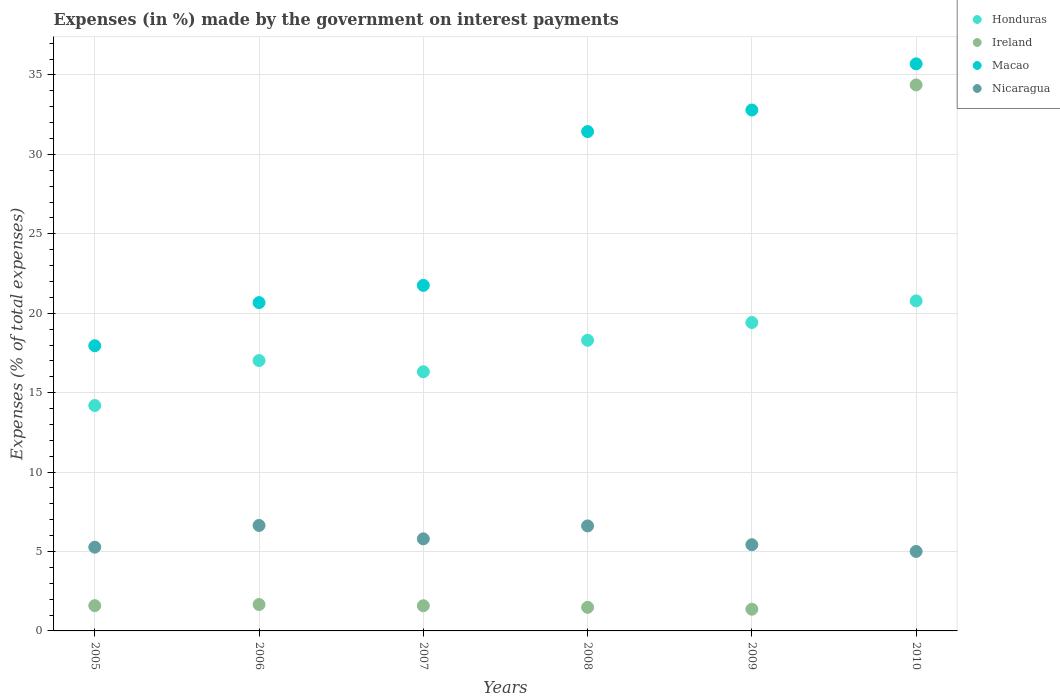What is the percentage of expenses made by the government on interest payments in Ireland in 2006?
Offer a terse response. 1.66. Across all years, what is the maximum percentage of expenses made by the government on interest payments in Macao?
Your answer should be very brief. 35.7. Across all years, what is the minimum percentage of expenses made by the government on interest payments in Honduras?
Your answer should be compact. 14.19. In which year was the percentage of expenses made by the government on interest payments in Macao maximum?
Offer a very short reply. 2010. In which year was the percentage of expenses made by the government on interest payments in Ireland minimum?
Offer a terse response. 2009. What is the total percentage of expenses made by the government on interest payments in Ireland in the graph?
Your answer should be very brief. 42.06. What is the difference between the percentage of expenses made by the government on interest payments in Ireland in 2008 and that in 2010?
Make the answer very short. -32.89. What is the difference between the percentage of expenses made by the government on interest payments in Nicaragua in 2006 and the percentage of expenses made by the government on interest payments in Macao in 2005?
Make the answer very short. -11.31. What is the average percentage of expenses made by the government on interest payments in Macao per year?
Give a very brief answer. 26.72. In the year 2006, what is the difference between the percentage of expenses made by the government on interest payments in Macao and percentage of expenses made by the government on interest payments in Nicaragua?
Your answer should be very brief. 14.03. In how many years, is the percentage of expenses made by the government on interest payments in Honduras greater than 29 %?
Make the answer very short. 0. What is the ratio of the percentage of expenses made by the government on interest payments in Nicaragua in 2005 to that in 2009?
Your answer should be very brief. 0.97. What is the difference between the highest and the second highest percentage of expenses made by the government on interest payments in Nicaragua?
Offer a very short reply. 0.03. What is the difference between the highest and the lowest percentage of expenses made by the government on interest payments in Nicaragua?
Offer a terse response. 1.64. In how many years, is the percentage of expenses made by the government on interest payments in Nicaragua greater than the average percentage of expenses made by the government on interest payments in Nicaragua taken over all years?
Provide a succinct answer. 3. Is the sum of the percentage of expenses made by the government on interest payments in Ireland in 2006 and 2008 greater than the maximum percentage of expenses made by the government on interest payments in Honduras across all years?
Offer a very short reply. No. Is it the case that in every year, the sum of the percentage of expenses made by the government on interest payments in Honduras and percentage of expenses made by the government on interest payments in Ireland  is greater than the sum of percentage of expenses made by the government on interest payments in Macao and percentage of expenses made by the government on interest payments in Nicaragua?
Your answer should be compact. Yes. Is the percentage of expenses made by the government on interest payments in Macao strictly less than the percentage of expenses made by the government on interest payments in Nicaragua over the years?
Your answer should be very brief. No. How many dotlines are there?
Make the answer very short. 4. What is the difference between two consecutive major ticks on the Y-axis?
Your response must be concise. 5. Are the values on the major ticks of Y-axis written in scientific E-notation?
Your response must be concise. No. Does the graph contain any zero values?
Make the answer very short. No. Does the graph contain grids?
Your answer should be compact. Yes. Where does the legend appear in the graph?
Your response must be concise. Top right. How are the legend labels stacked?
Your response must be concise. Vertical. What is the title of the graph?
Offer a very short reply. Expenses (in %) made by the government on interest payments. What is the label or title of the X-axis?
Offer a very short reply. Years. What is the label or title of the Y-axis?
Keep it short and to the point. Expenses (% of total expenses). What is the Expenses (% of total expenses) of Honduras in 2005?
Your answer should be compact. 14.19. What is the Expenses (% of total expenses) of Ireland in 2005?
Provide a succinct answer. 1.59. What is the Expenses (% of total expenses) of Macao in 2005?
Give a very brief answer. 17.95. What is the Expenses (% of total expenses) in Nicaragua in 2005?
Keep it short and to the point. 5.27. What is the Expenses (% of total expenses) of Honduras in 2006?
Provide a succinct answer. 17.02. What is the Expenses (% of total expenses) of Ireland in 2006?
Make the answer very short. 1.66. What is the Expenses (% of total expenses) in Macao in 2006?
Your answer should be very brief. 20.67. What is the Expenses (% of total expenses) of Nicaragua in 2006?
Make the answer very short. 6.64. What is the Expenses (% of total expenses) in Honduras in 2007?
Your answer should be very brief. 16.32. What is the Expenses (% of total expenses) of Ireland in 2007?
Your answer should be very brief. 1.58. What is the Expenses (% of total expenses) in Macao in 2007?
Make the answer very short. 21.75. What is the Expenses (% of total expenses) of Nicaragua in 2007?
Ensure brevity in your answer.  5.8. What is the Expenses (% of total expenses) in Honduras in 2008?
Offer a very short reply. 18.3. What is the Expenses (% of total expenses) of Ireland in 2008?
Give a very brief answer. 1.49. What is the Expenses (% of total expenses) in Macao in 2008?
Your answer should be very brief. 31.44. What is the Expenses (% of total expenses) of Nicaragua in 2008?
Provide a succinct answer. 6.61. What is the Expenses (% of total expenses) in Honduras in 2009?
Your response must be concise. 19.42. What is the Expenses (% of total expenses) of Ireland in 2009?
Your response must be concise. 1.37. What is the Expenses (% of total expenses) of Macao in 2009?
Ensure brevity in your answer.  32.8. What is the Expenses (% of total expenses) of Nicaragua in 2009?
Ensure brevity in your answer.  5.43. What is the Expenses (% of total expenses) in Honduras in 2010?
Offer a very short reply. 20.78. What is the Expenses (% of total expenses) in Ireland in 2010?
Make the answer very short. 34.37. What is the Expenses (% of total expenses) of Macao in 2010?
Offer a very short reply. 35.7. What is the Expenses (% of total expenses) in Nicaragua in 2010?
Give a very brief answer. 5. Across all years, what is the maximum Expenses (% of total expenses) in Honduras?
Offer a terse response. 20.78. Across all years, what is the maximum Expenses (% of total expenses) in Ireland?
Ensure brevity in your answer.  34.37. Across all years, what is the maximum Expenses (% of total expenses) of Macao?
Provide a short and direct response. 35.7. Across all years, what is the maximum Expenses (% of total expenses) of Nicaragua?
Keep it short and to the point. 6.64. Across all years, what is the minimum Expenses (% of total expenses) of Honduras?
Keep it short and to the point. 14.19. Across all years, what is the minimum Expenses (% of total expenses) in Ireland?
Your answer should be compact. 1.37. Across all years, what is the minimum Expenses (% of total expenses) in Macao?
Ensure brevity in your answer.  17.95. Across all years, what is the minimum Expenses (% of total expenses) in Nicaragua?
Your response must be concise. 5. What is the total Expenses (% of total expenses) in Honduras in the graph?
Offer a very short reply. 106.02. What is the total Expenses (% of total expenses) of Ireland in the graph?
Give a very brief answer. 42.06. What is the total Expenses (% of total expenses) in Macao in the graph?
Ensure brevity in your answer.  160.31. What is the total Expenses (% of total expenses) in Nicaragua in the graph?
Ensure brevity in your answer.  34.75. What is the difference between the Expenses (% of total expenses) of Honduras in 2005 and that in 2006?
Ensure brevity in your answer.  -2.83. What is the difference between the Expenses (% of total expenses) of Ireland in 2005 and that in 2006?
Provide a short and direct response. -0.07. What is the difference between the Expenses (% of total expenses) of Macao in 2005 and that in 2006?
Ensure brevity in your answer.  -2.72. What is the difference between the Expenses (% of total expenses) of Nicaragua in 2005 and that in 2006?
Keep it short and to the point. -1.37. What is the difference between the Expenses (% of total expenses) in Honduras in 2005 and that in 2007?
Provide a succinct answer. -2.13. What is the difference between the Expenses (% of total expenses) in Ireland in 2005 and that in 2007?
Your response must be concise. 0.01. What is the difference between the Expenses (% of total expenses) of Macao in 2005 and that in 2007?
Provide a succinct answer. -3.8. What is the difference between the Expenses (% of total expenses) of Nicaragua in 2005 and that in 2007?
Your answer should be very brief. -0.52. What is the difference between the Expenses (% of total expenses) of Honduras in 2005 and that in 2008?
Offer a very short reply. -4.11. What is the difference between the Expenses (% of total expenses) in Ireland in 2005 and that in 2008?
Offer a terse response. 0.1. What is the difference between the Expenses (% of total expenses) of Macao in 2005 and that in 2008?
Your answer should be very brief. -13.48. What is the difference between the Expenses (% of total expenses) of Nicaragua in 2005 and that in 2008?
Your answer should be very brief. -1.34. What is the difference between the Expenses (% of total expenses) in Honduras in 2005 and that in 2009?
Offer a terse response. -5.23. What is the difference between the Expenses (% of total expenses) in Ireland in 2005 and that in 2009?
Offer a terse response. 0.22. What is the difference between the Expenses (% of total expenses) of Macao in 2005 and that in 2009?
Offer a very short reply. -14.84. What is the difference between the Expenses (% of total expenses) in Nicaragua in 2005 and that in 2009?
Provide a succinct answer. -0.15. What is the difference between the Expenses (% of total expenses) in Honduras in 2005 and that in 2010?
Your answer should be very brief. -6.59. What is the difference between the Expenses (% of total expenses) in Ireland in 2005 and that in 2010?
Offer a very short reply. -32.78. What is the difference between the Expenses (% of total expenses) in Macao in 2005 and that in 2010?
Offer a very short reply. -17.75. What is the difference between the Expenses (% of total expenses) of Nicaragua in 2005 and that in 2010?
Provide a short and direct response. 0.27. What is the difference between the Expenses (% of total expenses) of Honduras in 2006 and that in 2007?
Offer a very short reply. 0.7. What is the difference between the Expenses (% of total expenses) in Ireland in 2006 and that in 2007?
Provide a short and direct response. 0.08. What is the difference between the Expenses (% of total expenses) of Macao in 2006 and that in 2007?
Offer a very short reply. -1.08. What is the difference between the Expenses (% of total expenses) of Nicaragua in 2006 and that in 2007?
Ensure brevity in your answer.  0.84. What is the difference between the Expenses (% of total expenses) in Honduras in 2006 and that in 2008?
Your answer should be compact. -1.28. What is the difference between the Expenses (% of total expenses) of Ireland in 2006 and that in 2008?
Your answer should be very brief. 0.18. What is the difference between the Expenses (% of total expenses) of Macao in 2006 and that in 2008?
Ensure brevity in your answer.  -10.77. What is the difference between the Expenses (% of total expenses) in Nicaragua in 2006 and that in 2008?
Make the answer very short. 0.03. What is the difference between the Expenses (% of total expenses) of Honduras in 2006 and that in 2009?
Provide a succinct answer. -2.39. What is the difference between the Expenses (% of total expenses) of Ireland in 2006 and that in 2009?
Provide a short and direct response. 0.3. What is the difference between the Expenses (% of total expenses) in Macao in 2006 and that in 2009?
Ensure brevity in your answer.  -12.13. What is the difference between the Expenses (% of total expenses) in Nicaragua in 2006 and that in 2009?
Offer a terse response. 1.21. What is the difference between the Expenses (% of total expenses) in Honduras in 2006 and that in 2010?
Provide a short and direct response. -3.76. What is the difference between the Expenses (% of total expenses) in Ireland in 2006 and that in 2010?
Keep it short and to the point. -32.71. What is the difference between the Expenses (% of total expenses) of Macao in 2006 and that in 2010?
Keep it short and to the point. -15.03. What is the difference between the Expenses (% of total expenses) of Nicaragua in 2006 and that in 2010?
Give a very brief answer. 1.64. What is the difference between the Expenses (% of total expenses) of Honduras in 2007 and that in 2008?
Your answer should be compact. -1.98. What is the difference between the Expenses (% of total expenses) of Ireland in 2007 and that in 2008?
Make the answer very short. 0.1. What is the difference between the Expenses (% of total expenses) of Macao in 2007 and that in 2008?
Your answer should be very brief. -9.68. What is the difference between the Expenses (% of total expenses) of Nicaragua in 2007 and that in 2008?
Give a very brief answer. -0.81. What is the difference between the Expenses (% of total expenses) of Honduras in 2007 and that in 2009?
Offer a very short reply. -3.1. What is the difference between the Expenses (% of total expenses) in Ireland in 2007 and that in 2009?
Provide a succinct answer. 0.22. What is the difference between the Expenses (% of total expenses) in Macao in 2007 and that in 2009?
Ensure brevity in your answer.  -11.04. What is the difference between the Expenses (% of total expenses) of Nicaragua in 2007 and that in 2009?
Your answer should be very brief. 0.37. What is the difference between the Expenses (% of total expenses) of Honduras in 2007 and that in 2010?
Your answer should be compact. -4.46. What is the difference between the Expenses (% of total expenses) in Ireland in 2007 and that in 2010?
Your answer should be compact. -32.79. What is the difference between the Expenses (% of total expenses) of Macao in 2007 and that in 2010?
Offer a terse response. -13.95. What is the difference between the Expenses (% of total expenses) in Nicaragua in 2007 and that in 2010?
Your response must be concise. 0.79. What is the difference between the Expenses (% of total expenses) in Honduras in 2008 and that in 2009?
Make the answer very short. -1.12. What is the difference between the Expenses (% of total expenses) of Ireland in 2008 and that in 2009?
Keep it short and to the point. 0.12. What is the difference between the Expenses (% of total expenses) in Macao in 2008 and that in 2009?
Your answer should be compact. -1.36. What is the difference between the Expenses (% of total expenses) in Nicaragua in 2008 and that in 2009?
Provide a short and direct response. 1.18. What is the difference between the Expenses (% of total expenses) of Honduras in 2008 and that in 2010?
Offer a very short reply. -2.48. What is the difference between the Expenses (% of total expenses) in Ireland in 2008 and that in 2010?
Give a very brief answer. -32.89. What is the difference between the Expenses (% of total expenses) in Macao in 2008 and that in 2010?
Your answer should be compact. -4.26. What is the difference between the Expenses (% of total expenses) in Nicaragua in 2008 and that in 2010?
Your answer should be very brief. 1.61. What is the difference between the Expenses (% of total expenses) in Honduras in 2009 and that in 2010?
Your response must be concise. -1.36. What is the difference between the Expenses (% of total expenses) of Ireland in 2009 and that in 2010?
Your answer should be compact. -33.01. What is the difference between the Expenses (% of total expenses) in Macao in 2009 and that in 2010?
Offer a very short reply. -2.91. What is the difference between the Expenses (% of total expenses) of Nicaragua in 2009 and that in 2010?
Your answer should be very brief. 0.42. What is the difference between the Expenses (% of total expenses) in Honduras in 2005 and the Expenses (% of total expenses) in Ireland in 2006?
Ensure brevity in your answer.  12.53. What is the difference between the Expenses (% of total expenses) in Honduras in 2005 and the Expenses (% of total expenses) in Macao in 2006?
Ensure brevity in your answer.  -6.48. What is the difference between the Expenses (% of total expenses) of Honduras in 2005 and the Expenses (% of total expenses) of Nicaragua in 2006?
Ensure brevity in your answer.  7.55. What is the difference between the Expenses (% of total expenses) of Ireland in 2005 and the Expenses (% of total expenses) of Macao in 2006?
Provide a short and direct response. -19.08. What is the difference between the Expenses (% of total expenses) in Ireland in 2005 and the Expenses (% of total expenses) in Nicaragua in 2006?
Your response must be concise. -5.05. What is the difference between the Expenses (% of total expenses) in Macao in 2005 and the Expenses (% of total expenses) in Nicaragua in 2006?
Provide a succinct answer. 11.31. What is the difference between the Expenses (% of total expenses) in Honduras in 2005 and the Expenses (% of total expenses) in Ireland in 2007?
Ensure brevity in your answer.  12.61. What is the difference between the Expenses (% of total expenses) of Honduras in 2005 and the Expenses (% of total expenses) of Macao in 2007?
Give a very brief answer. -7.56. What is the difference between the Expenses (% of total expenses) in Honduras in 2005 and the Expenses (% of total expenses) in Nicaragua in 2007?
Provide a succinct answer. 8.39. What is the difference between the Expenses (% of total expenses) in Ireland in 2005 and the Expenses (% of total expenses) in Macao in 2007?
Keep it short and to the point. -20.16. What is the difference between the Expenses (% of total expenses) in Ireland in 2005 and the Expenses (% of total expenses) in Nicaragua in 2007?
Ensure brevity in your answer.  -4.21. What is the difference between the Expenses (% of total expenses) in Macao in 2005 and the Expenses (% of total expenses) in Nicaragua in 2007?
Keep it short and to the point. 12.16. What is the difference between the Expenses (% of total expenses) in Honduras in 2005 and the Expenses (% of total expenses) in Ireland in 2008?
Offer a terse response. 12.7. What is the difference between the Expenses (% of total expenses) in Honduras in 2005 and the Expenses (% of total expenses) in Macao in 2008?
Your answer should be compact. -17.25. What is the difference between the Expenses (% of total expenses) of Honduras in 2005 and the Expenses (% of total expenses) of Nicaragua in 2008?
Your answer should be very brief. 7.58. What is the difference between the Expenses (% of total expenses) in Ireland in 2005 and the Expenses (% of total expenses) in Macao in 2008?
Make the answer very short. -29.85. What is the difference between the Expenses (% of total expenses) of Ireland in 2005 and the Expenses (% of total expenses) of Nicaragua in 2008?
Offer a very short reply. -5.02. What is the difference between the Expenses (% of total expenses) in Macao in 2005 and the Expenses (% of total expenses) in Nicaragua in 2008?
Offer a terse response. 11.34. What is the difference between the Expenses (% of total expenses) of Honduras in 2005 and the Expenses (% of total expenses) of Ireland in 2009?
Ensure brevity in your answer.  12.82. What is the difference between the Expenses (% of total expenses) in Honduras in 2005 and the Expenses (% of total expenses) in Macao in 2009?
Ensure brevity in your answer.  -18.61. What is the difference between the Expenses (% of total expenses) of Honduras in 2005 and the Expenses (% of total expenses) of Nicaragua in 2009?
Ensure brevity in your answer.  8.76. What is the difference between the Expenses (% of total expenses) in Ireland in 2005 and the Expenses (% of total expenses) in Macao in 2009?
Provide a short and direct response. -31.2. What is the difference between the Expenses (% of total expenses) in Ireland in 2005 and the Expenses (% of total expenses) in Nicaragua in 2009?
Keep it short and to the point. -3.84. What is the difference between the Expenses (% of total expenses) in Macao in 2005 and the Expenses (% of total expenses) in Nicaragua in 2009?
Your response must be concise. 12.53. What is the difference between the Expenses (% of total expenses) of Honduras in 2005 and the Expenses (% of total expenses) of Ireland in 2010?
Your answer should be very brief. -20.18. What is the difference between the Expenses (% of total expenses) of Honduras in 2005 and the Expenses (% of total expenses) of Macao in 2010?
Offer a very short reply. -21.51. What is the difference between the Expenses (% of total expenses) of Honduras in 2005 and the Expenses (% of total expenses) of Nicaragua in 2010?
Your answer should be compact. 9.19. What is the difference between the Expenses (% of total expenses) in Ireland in 2005 and the Expenses (% of total expenses) in Macao in 2010?
Offer a terse response. -34.11. What is the difference between the Expenses (% of total expenses) of Ireland in 2005 and the Expenses (% of total expenses) of Nicaragua in 2010?
Ensure brevity in your answer.  -3.41. What is the difference between the Expenses (% of total expenses) of Macao in 2005 and the Expenses (% of total expenses) of Nicaragua in 2010?
Make the answer very short. 12.95. What is the difference between the Expenses (% of total expenses) of Honduras in 2006 and the Expenses (% of total expenses) of Ireland in 2007?
Your response must be concise. 15.44. What is the difference between the Expenses (% of total expenses) in Honduras in 2006 and the Expenses (% of total expenses) in Macao in 2007?
Ensure brevity in your answer.  -4.73. What is the difference between the Expenses (% of total expenses) in Honduras in 2006 and the Expenses (% of total expenses) in Nicaragua in 2007?
Ensure brevity in your answer.  11.22. What is the difference between the Expenses (% of total expenses) in Ireland in 2006 and the Expenses (% of total expenses) in Macao in 2007?
Provide a short and direct response. -20.09. What is the difference between the Expenses (% of total expenses) in Ireland in 2006 and the Expenses (% of total expenses) in Nicaragua in 2007?
Your response must be concise. -4.13. What is the difference between the Expenses (% of total expenses) of Macao in 2006 and the Expenses (% of total expenses) of Nicaragua in 2007?
Your answer should be very brief. 14.87. What is the difference between the Expenses (% of total expenses) in Honduras in 2006 and the Expenses (% of total expenses) in Ireland in 2008?
Your answer should be compact. 15.54. What is the difference between the Expenses (% of total expenses) in Honduras in 2006 and the Expenses (% of total expenses) in Macao in 2008?
Your answer should be compact. -14.42. What is the difference between the Expenses (% of total expenses) in Honduras in 2006 and the Expenses (% of total expenses) in Nicaragua in 2008?
Your answer should be very brief. 10.41. What is the difference between the Expenses (% of total expenses) of Ireland in 2006 and the Expenses (% of total expenses) of Macao in 2008?
Offer a very short reply. -29.78. What is the difference between the Expenses (% of total expenses) in Ireland in 2006 and the Expenses (% of total expenses) in Nicaragua in 2008?
Provide a short and direct response. -4.95. What is the difference between the Expenses (% of total expenses) of Macao in 2006 and the Expenses (% of total expenses) of Nicaragua in 2008?
Make the answer very short. 14.06. What is the difference between the Expenses (% of total expenses) of Honduras in 2006 and the Expenses (% of total expenses) of Ireland in 2009?
Offer a very short reply. 15.66. What is the difference between the Expenses (% of total expenses) in Honduras in 2006 and the Expenses (% of total expenses) in Macao in 2009?
Make the answer very short. -15.77. What is the difference between the Expenses (% of total expenses) of Honduras in 2006 and the Expenses (% of total expenses) of Nicaragua in 2009?
Your answer should be very brief. 11.59. What is the difference between the Expenses (% of total expenses) in Ireland in 2006 and the Expenses (% of total expenses) in Macao in 2009?
Give a very brief answer. -31.13. What is the difference between the Expenses (% of total expenses) of Ireland in 2006 and the Expenses (% of total expenses) of Nicaragua in 2009?
Make the answer very short. -3.76. What is the difference between the Expenses (% of total expenses) in Macao in 2006 and the Expenses (% of total expenses) in Nicaragua in 2009?
Offer a very short reply. 15.24. What is the difference between the Expenses (% of total expenses) of Honduras in 2006 and the Expenses (% of total expenses) of Ireland in 2010?
Your answer should be very brief. -17.35. What is the difference between the Expenses (% of total expenses) of Honduras in 2006 and the Expenses (% of total expenses) of Macao in 2010?
Give a very brief answer. -18.68. What is the difference between the Expenses (% of total expenses) of Honduras in 2006 and the Expenses (% of total expenses) of Nicaragua in 2010?
Ensure brevity in your answer.  12.02. What is the difference between the Expenses (% of total expenses) in Ireland in 2006 and the Expenses (% of total expenses) in Macao in 2010?
Provide a succinct answer. -34.04. What is the difference between the Expenses (% of total expenses) in Ireland in 2006 and the Expenses (% of total expenses) in Nicaragua in 2010?
Your answer should be compact. -3.34. What is the difference between the Expenses (% of total expenses) in Macao in 2006 and the Expenses (% of total expenses) in Nicaragua in 2010?
Keep it short and to the point. 15.67. What is the difference between the Expenses (% of total expenses) in Honduras in 2007 and the Expenses (% of total expenses) in Ireland in 2008?
Keep it short and to the point. 14.83. What is the difference between the Expenses (% of total expenses) in Honduras in 2007 and the Expenses (% of total expenses) in Macao in 2008?
Give a very brief answer. -15.12. What is the difference between the Expenses (% of total expenses) in Honduras in 2007 and the Expenses (% of total expenses) in Nicaragua in 2008?
Provide a short and direct response. 9.71. What is the difference between the Expenses (% of total expenses) of Ireland in 2007 and the Expenses (% of total expenses) of Macao in 2008?
Provide a short and direct response. -29.85. What is the difference between the Expenses (% of total expenses) of Ireland in 2007 and the Expenses (% of total expenses) of Nicaragua in 2008?
Offer a terse response. -5.03. What is the difference between the Expenses (% of total expenses) of Macao in 2007 and the Expenses (% of total expenses) of Nicaragua in 2008?
Make the answer very short. 15.14. What is the difference between the Expenses (% of total expenses) of Honduras in 2007 and the Expenses (% of total expenses) of Ireland in 2009?
Give a very brief answer. 14.95. What is the difference between the Expenses (% of total expenses) of Honduras in 2007 and the Expenses (% of total expenses) of Macao in 2009?
Give a very brief answer. -16.48. What is the difference between the Expenses (% of total expenses) of Honduras in 2007 and the Expenses (% of total expenses) of Nicaragua in 2009?
Ensure brevity in your answer.  10.89. What is the difference between the Expenses (% of total expenses) in Ireland in 2007 and the Expenses (% of total expenses) in Macao in 2009?
Make the answer very short. -31.21. What is the difference between the Expenses (% of total expenses) in Ireland in 2007 and the Expenses (% of total expenses) in Nicaragua in 2009?
Your response must be concise. -3.84. What is the difference between the Expenses (% of total expenses) in Macao in 2007 and the Expenses (% of total expenses) in Nicaragua in 2009?
Provide a succinct answer. 16.33. What is the difference between the Expenses (% of total expenses) of Honduras in 2007 and the Expenses (% of total expenses) of Ireland in 2010?
Your answer should be compact. -18.06. What is the difference between the Expenses (% of total expenses) of Honduras in 2007 and the Expenses (% of total expenses) of Macao in 2010?
Give a very brief answer. -19.39. What is the difference between the Expenses (% of total expenses) in Honduras in 2007 and the Expenses (% of total expenses) in Nicaragua in 2010?
Keep it short and to the point. 11.31. What is the difference between the Expenses (% of total expenses) in Ireland in 2007 and the Expenses (% of total expenses) in Macao in 2010?
Offer a terse response. -34.12. What is the difference between the Expenses (% of total expenses) in Ireland in 2007 and the Expenses (% of total expenses) in Nicaragua in 2010?
Your response must be concise. -3.42. What is the difference between the Expenses (% of total expenses) in Macao in 2007 and the Expenses (% of total expenses) in Nicaragua in 2010?
Keep it short and to the point. 16.75. What is the difference between the Expenses (% of total expenses) of Honduras in 2008 and the Expenses (% of total expenses) of Ireland in 2009?
Provide a succinct answer. 16.93. What is the difference between the Expenses (% of total expenses) in Honduras in 2008 and the Expenses (% of total expenses) in Macao in 2009?
Your answer should be compact. -14.5. What is the difference between the Expenses (% of total expenses) in Honduras in 2008 and the Expenses (% of total expenses) in Nicaragua in 2009?
Your answer should be very brief. 12.87. What is the difference between the Expenses (% of total expenses) in Ireland in 2008 and the Expenses (% of total expenses) in Macao in 2009?
Provide a short and direct response. -31.31. What is the difference between the Expenses (% of total expenses) in Ireland in 2008 and the Expenses (% of total expenses) in Nicaragua in 2009?
Make the answer very short. -3.94. What is the difference between the Expenses (% of total expenses) in Macao in 2008 and the Expenses (% of total expenses) in Nicaragua in 2009?
Provide a short and direct response. 26.01. What is the difference between the Expenses (% of total expenses) in Honduras in 2008 and the Expenses (% of total expenses) in Ireland in 2010?
Offer a terse response. -16.08. What is the difference between the Expenses (% of total expenses) of Honduras in 2008 and the Expenses (% of total expenses) of Macao in 2010?
Make the answer very short. -17.4. What is the difference between the Expenses (% of total expenses) of Honduras in 2008 and the Expenses (% of total expenses) of Nicaragua in 2010?
Your answer should be compact. 13.29. What is the difference between the Expenses (% of total expenses) of Ireland in 2008 and the Expenses (% of total expenses) of Macao in 2010?
Keep it short and to the point. -34.22. What is the difference between the Expenses (% of total expenses) of Ireland in 2008 and the Expenses (% of total expenses) of Nicaragua in 2010?
Keep it short and to the point. -3.52. What is the difference between the Expenses (% of total expenses) in Macao in 2008 and the Expenses (% of total expenses) in Nicaragua in 2010?
Offer a terse response. 26.43. What is the difference between the Expenses (% of total expenses) of Honduras in 2009 and the Expenses (% of total expenses) of Ireland in 2010?
Your answer should be compact. -14.96. What is the difference between the Expenses (% of total expenses) in Honduras in 2009 and the Expenses (% of total expenses) in Macao in 2010?
Your response must be concise. -16.29. What is the difference between the Expenses (% of total expenses) of Honduras in 2009 and the Expenses (% of total expenses) of Nicaragua in 2010?
Offer a terse response. 14.41. What is the difference between the Expenses (% of total expenses) in Ireland in 2009 and the Expenses (% of total expenses) in Macao in 2010?
Ensure brevity in your answer.  -34.34. What is the difference between the Expenses (% of total expenses) of Ireland in 2009 and the Expenses (% of total expenses) of Nicaragua in 2010?
Give a very brief answer. -3.64. What is the difference between the Expenses (% of total expenses) in Macao in 2009 and the Expenses (% of total expenses) in Nicaragua in 2010?
Give a very brief answer. 27.79. What is the average Expenses (% of total expenses) in Honduras per year?
Provide a succinct answer. 17.67. What is the average Expenses (% of total expenses) of Ireland per year?
Keep it short and to the point. 7.01. What is the average Expenses (% of total expenses) of Macao per year?
Keep it short and to the point. 26.72. What is the average Expenses (% of total expenses) of Nicaragua per year?
Your answer should be compact. 5.79. In the year 2005, what is the difference between the Expenses (% of total expenses) of Honduras and Expenses (% of total expenses) of Ireland?
Your response must be concise. 12.6. In the year 2005, what is the difference between the Expenses (% of total expenses) in Honduras and Expenses (% of total expenses) in Macao?
Offer a very short reply. -3.76. In the year 2005, what is the difference between the Expenses (% of total expenses) of Honduras and Expenses (% of total expenses) of Nicaragua?
Make the answer very short. 8.92. In the year 2005, what is the difference between the Expenses (% of total expenses) in Ireland and Expenses (% of total expenses) in Macao?
Provide a short and direct response. -16.36. In the year 2005, what is the difference between the Expenses (% of total expenses) in Ireland and Expenses (% of total expenses) in Nicaragua?
Keep it short and to the point. -3.68. In the year 2005, what is the difference between the Expenses (% of total expenses) in Macao and Expenses (% of total expenses) in Nicaragua?
Your answer should be very brief. 12.68. In the year 2006, what is the difference between the Expenses (% of total expenses) of Honduras and Expenses (% of total expenses) of Ireland?
Ensure brevity in your answer.  15.36. In the year 2006, what is the difference between the Expenses (% of total expenses) of Honduras and Expenses (% of total expenses) of Macao?
Provide a succinct answer. -3.65. In the year 2006, what is the difference between the Expenses (% of total expenses) of Honduras and Expenses (% of total expenses) of Nicaragua?
Offer a very short reply. 10.38. In the year 2006, what is the difference between the Expenses (% of total expenses) in Ireland and Expenses (% of total expenses) in Macao?
Offer a very short reply. -19.01. In the year 2006, what is the difference between the Expenses (% of total expenses) of Ireland and Expenses (% of total expenses) of Nicaragua?
Make the answer very short. -4.98. In the year 2006, what is the difference between the Expenses (% of total expenses) in Macao and Expenses (% of total expenses) in Nicaragua?
Provide a succinct answer. 14.03. In the year 2007, what is the difference between the Expenses (% of total expenses) in Honduras and Expenses (% of total expenses) in Ireland?
Make the answer very short. 14.73. In the year 2007, what is the difference between the Expenses (% of total expenses) of Honduras and Expenses (% of total expenses) of Macao?
Your answer should be very brief. -5.44. In the year 2007, what is the difference between the Expenses (% of total expenses) in Honduras and Expenses (% of total expenses) in Nicaragua?
Offer a very short reply. 10.52. In the year 2007, what is the difference between the Expenses (% of total expenses) in Ireland and Expenses (% of total expenses) in Macao?
Ensure brevity in your answer.  -20.17. In the year 2007, what is the difference between the Expenses (% of total expenses) of Ireland and Expenses (% of total expenses) of Nicaragua?
Make the answer very short. -4.21. In the year 2007, what is the difference between the Expenses (% of total expenses) in Macao and Expenses (% of total expenses) in Nicaragua?
Make the answer very short. 15.96. In the year 2008, what is the difference between the Expenses (% of total expenses) of Honduras and Expenses (% of total expenses) of Ireland?
Your response must be concise. 16.81. In the year 2008, what is the difference between the Expenses (% of total expenses) of Honduras and Expenses (% of total expenses) of Macao?
Your response must be concise. -13.14. In the year 2008, what is the difference between the Expenses (% of total expenses) of Honduras and Expenses (% of total expenses) of Nicaragua?
Provide a succinct answer. 11.69. In the year 2008, what is the difference between the Expenses (% of total expenses) of Ireland and Expenses (% of total expenses) of Macao?
Ensure brevity in your answer.  -29.95. In the year 2008, what is the difference between the Expenses (% of total expenses) in Ireland and Expenses (% of total expenses) in Nicaragua?
Provide a short and direct response. -5.13. In the year 2008, what is the difference between the Expenses (% of total expenses) in Macao and Expenses (% of total expenses) in Nicaragua?
Provide a succinct answer. 24.83. In the year 2009, what is the difference between the Expenses (% of total expenses) of Honduras and Expenses (% of total expenses) of Ireland?
Provide a short and direct response. 18.05. In the year 2009, what is the difference between the Expenses (% of total expenses) of Honduras and Expenses (% of total expenses) of Macao?
Make the answer very short. -13.38. In the year 2009, what is the difference between the Expenses (% of total expenses) of Honduras and Expenses (% of total expenses) of Nicaragua?
Offer a terse response. 13.99. In the year 2009, what is the difference between the Expenses (% of total expenses) of Ireland and Expenses (% of total expenses) of Macao?
Your answer should be compact. -31.43. In the year 2009, what is the difference between the Expenses (% of total expenses) in Ireland and Expenses (% of total expenses) in Nicaragua?
Your answer should be very brief. -4.06. In the year 2009, what is the difference between the Expenses (% of total expenses) of Macao and Expenses (% of total expenses) of Nicaragua?
Offer a terse response. 27.37. In the year 2010, what is the difference between the Expenses (% of total expenses) in Honduras and Expenses (% of total expenses) in Ireland?
Ensure brevity in your answer.  -13.6. In the year 2010, what is the difference between the Expenses (% of total expenses) of Honduras and Expenses (% of total expenses) of Macao?
Keep it short and to the point. -14.92. In the year 2010, what is the difference between the Expenses (% of total expenses) of Honduras and Expenses (% of total expenses) of Nicaragua?
Your response must be concise. 15.77. In the year 2010, what is the difference between the Expenses (% of total expenses) in Ireland and Expenses (% of total expenses) in Macao?
Your answer should be very brief. -1.33. In the year 2010, what is the difference between the Expenses (% of total expenses) in Ireland and Expenses (% of total expenses) in Nicaragua?
Ensure brevity in your answer.  29.37. In the year 2010, what is the difference between the Expenses (% of total expenses) of Macao and Expenses (% of total expenses) of Nicaragua?
Your answer should be very brief. 30.7. What is the ratio of the Expenses (% of total expenses) in Honduras in 2005 to that in 2006?
Keep it short and to the point. 0.83. What is the ratio of the Expenses (% of total expenses) in Ireland in 2005 to that in 2006?
Keep it short and to the point. 0.96. What is the ratio of the Expenses (% of total expenses) of Macao in 2005 to that in 2006?
Offer a terse response. 0.87. What is the ratio of the Expenses (% of total expenses) in Nicaragua in 2005 to that in 2006?
Keep it short and to the point. 0.79. What is the ratio of the Expenses (% of total expenses) of Honduras in 2005 to that in 2007?
Offer a terse response. 0.87. What is the ratio of the Expenses (% of total expenses) in Ireland in 2005 to that in 2007?
Offer a terse response. 1. What is the ratio of the Expenses (% of total expenses) in Macao in 2005 to that in 2007?
Provide a short and direct response. 0.83. What is the ratio of the Expenses (% of total expenses) of Nicaragua in 2005 to that in 2007?
Offer a terse response. 0.91. What is the ratio of the Expenses (% of total expenses) in Honduras in 2005 to that in 2008?
Your answer should be very brief. 0.78. What is the ratio of the Expenses (% of total expenses) in Ireland in 2005 to that in 2008?
Keep it short and to the point. 1.07. What is the ratio of the Expenses (% of total expenses) of Macao in 2005 to that in 2008?
Ensure brevity in your answer.  0.57. What is the ratio of the Expenses (% of total expenses) of Nicaragua in 2005 to that in 2008?
Ensure brevity in your answer.  0.8. What is the ratio of the Expenses (% of total expenses) in Honduras in 2005 to that in 2009?
Your answer should be compact. 0.73. What is the ratio of the Expenses (% of total expenses) of Ireland in 2005 to that in 2009?
Ensure brevity in your answer.  1.16. What is the ratio of the Expenses (% of total expenses) in Macao in 2005 to that in 2009?
Make the answer very short. 0.55. What is the ratio of the Expenses (% of total expenses) in Nicaragua in 2005 to that in 2009?
Your answer should be compact. 0.97. What is the ratio of the Expenses (% of total expenses) of Honduras in 2005 to that in 2010?
Your answer should be very brief. 0.68. What is the ratio of the Expenses (% of total expenses) in Ireland in 2005 to that in 2010?
Offer a very short reply. 0.05. What is the ratio of the Expenses (% of total expenses) of Macao in 2005 to that in 2010?
Keep it short and to the point. 0.5. What is the ratio of the Expenses (% of total expenses) in Nicaragua in 2005 to that in 2010?
Give a very brief answer. 1.05. What is the ratio of the Expenses (% of total expenses) in Honduras in 2006 to that in 2007?
Provide a short and direct response. 1.04. What is the ratio of the Expenses (% of total expenses) in Ireland in 2006 to that in 2007?
Keep it short and to the point. 1.05. What is the ratio of the Expenses (% of total expenses) in Macao in 2006 to that in 2007?
Make the answer very short. 0.95. What is the ratio of the Expenses (% of total expenses) of Nicaragua in 2006 to that in 2007?
Provide a short and direct response. 1.15. What is the ratio of the Expenses (% of total expenses) of Honduras in 2006 to that in 2008?
Your answer should be very brief. 0.93. What is the ratio of the Expenses (% of total expenses) in Ireland in 2006 to that in 2008?
Your response must be concise. 1.12. What is the ratio of the Expenses (% of total expenses) of Macao in 2006 to that in 2008?
Provide a short and direct response. 0.66. What is the ratio of the Expenses (% of total expenses) of Nicaragua in 2006 to that in 2008?
Ensure brevity in your answer.  1. What is the ratio of the Expenses (% of total expenses) of Honduras in 2006 to that in 2009?
Give a very brief answer. 0.88. What is the ratio of the Expenses (% of total expenses) in Ireland in 2006 to that in 2009?
Provide a succinct answer. 1.22. What is the ratio of the Expenses (% of total expenses) of Macao in 2006 to that in 2009?
Make the answer very short. 0.63. What is the ratio of the Expenses (% of total expenses) of Nicaragua in 2006 to that in 2009?
Provide a succinct answer. 1.22. What is the ratio of the Expenses (% of total expenses) in Honduras in 2006 to that in 2010?
Ensure brevity in your answer.  0.82. What is the ratio of the Expenses (% of total expenses) in Ireland in 2006 to that in 2010?
Your response must be concise. 0.05. What is the ratio of the Expenses (% of total expenses) in Macao in 2006 to that in 2010?
Your answer should be compact. 0.58. What is the ratio of the Expenses (% of total expenses) of Nicaragua in 2006 to that in 2010?
Your answer should be very brief. 1.33. What is the ratio of the Expenses (% of total expenses) in Honduras in 2007 to that in 2008?
Offer a terse response. 0.89. What is the ratio of the Expenses (% of total expenses) of Ireland in 2007 to that in 2008?
Your response must be concise. 1.07. What is the ratio of the Expenses (% of total expenses) of Macao in 2007 to that in 2008?
Provide a succinct answer. 0.69. What is the ratio of the Expenses (% of total expenses) in Nicaragua in 2007 to that in 2008?
Make the answer very short. 0.88. What is the ratio of the Expenses (% of total expenses) of Honduras in 2007 to that in 2009?
Provide a short and direct response. 0.84. What is the ratio of the Expenses (% of total expenses) of Ireland in 2007 to that in 2009?
Offer a terse response. 1.16. What is the ratio of the Expenses (% of total expenses) of Macao in 2007 to that in 2009?
Keep it short and to the point. 0.66. What is the ratio of the Expenses (% of total expenses) of Nicaragua in 2007 to that in 2009?
Offer a very short reply. 1.07. What is the ratio of the Expenses (% of total expenses) in Honduras in 2007 to that in 2010?
Your answer should be compact. 0.79. What is the ratio of the Expenses (% of total expenses) of Ireland in 2007 to that in 2010?
Your answer should be compact. 0.05. What is the ratio of the Expenses (% of total expenses) of Macao in 2007 to that in 2010?
Your answer should be compact. 0.61. What is the ratio of the Expenses (% of total expenses) in Nicaragua in 2007 to that in 2010?
Offer a terse response. 1.16. What is the ratio of the Expenses (% of total expenses) of Honduras in 2008 to that in 2009?
Provide a succinct answer. 0.94. What is the ratio of the Expenses (% of total expenses) of Ireland in 2008 to that in 2009?
Your answer should be very brief. 1.09. What is the ratio of the Expenses (% of total expenses) in Macao in 2008 to that in 2009?
Keep it short and to the point. 0.96. What is the ratio of the Expenses (% of total expenses) in Nicaragua in 2008 to that in 2009?
Make the answer very short. 1.22. What is the ratio of the Expenses (% of total expenses) of Honduras in 2008 to that in 2010?
Offer a terse response. 0.88. What is the ratio of the Expenses (% of total expenses) in Ireland in 2008 to that in 2010?
Your answer should be very brief. 0.04. What is the ratio of the Expenses (% of total expenses) in Macao in 2008 to that in 2010?
Your answer should be compact. 0.88. What is the ratio of the Expenses (% of total expenses) in Nicaragua in 2008 to that in 2010?
Your answer should be compact. 1.32. What is the ratio of the Expenses (% of total expenses) of Honduras in 2009 to that in 2010?
Offer a very short reply. 0.93. What is the ratio of the Expenses (% of total expenses) of Ireland in 2009 to that in 2010?
Offer a very short reply. 0.04. What is the ratio of the Expenses (% of total expenses) of Macao in 2009 to that in 2010?
Ensure brevity in your answer.  0.92. What is the ratio of the Expenses (% of total expenses) in Nicaragua in 2009 to that in 2010?
Give a very brief answer. 1.08. What is the difference between the highest and the second highest Expenses (% of total expenses) in Honduras?
Your response must be concise. 1.36. What is the difference between the highest and the second highest Expenses (% of total expenses) of Ireland?
Give a very brief answer. 32.71. What is the difference between the highest and the second highest Expenses (% of total expenses) of Macao?
Ensure brevity in your answer.  2.91. What is the difference between the highest and the second highest Expenses (% of total expenses) of Nicaragua?
Offer a very short reply. 0.03. What is the difference between the highest and the lowest Expenses (% of total expenses) in Honduras?
Provide a succinct answer. 6.59. What is the difference between the highest and the lowest Expenses (% of total expenses) of Ireland?
Your answer should be very brief. 33.01. What is the difference between the highest and the lowest Expenses (% of total expenses) in Macao?
Offer a terse response. 17.75. What is the difference between the highest and the lowest Expenses (% of total expenses) of Nicaragua?
Your response must be concise. 1.64. 